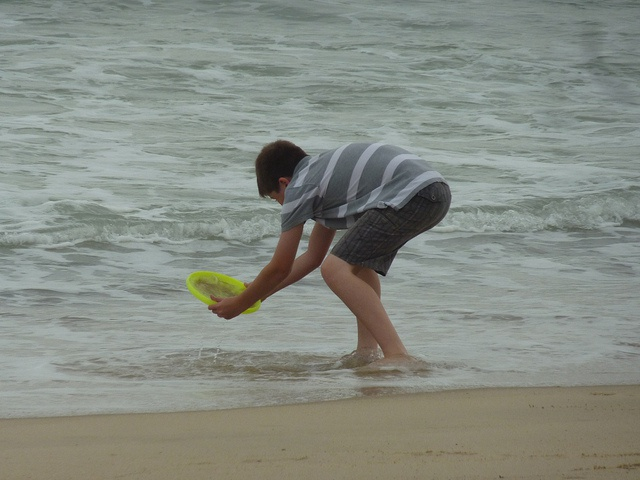Describe the objects in this image and their specific colors. I can see people in gray, black, darkgray, and maroon tones and frisbee in gray, olive, and darkgray tones in this image. 